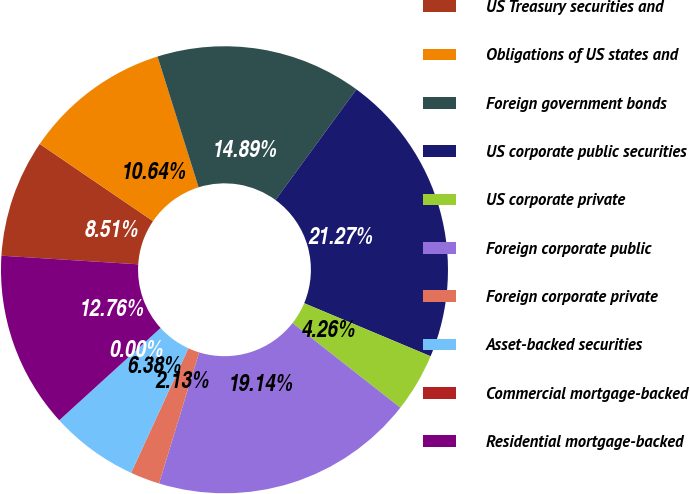<chart> <loc_0><loc_0><loc_500><loc_500><pie_chart><fcel>US Treasury securities and<fcel>Obligations of US states and<fcel>Foreign government bonds<fcel>US corporate public securities<fcel>US corporate private<fcel>Foreign corporate public<fcel>Foreign corporate private<fcel>Asset-backed securities<fcel>Commercial mortgage-backed<fcel>Residential mortgage-backed<nl><fcel>8.51%<fcel>10.64%<fcel>14.89%<fcel>21.27%<fcel>4.26%<fcel>19.14%<fcel>2.13%<fcel>6.38%<fcel>0.0%<fcel>12.76%<nl></chart> 